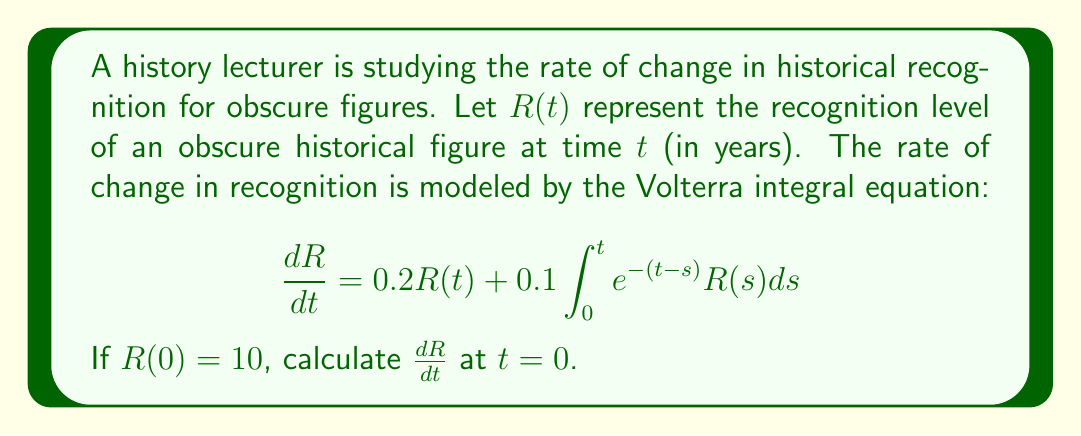What is the answer to this math problem? To solve this problem, we need to follow these steps:

1) The Volterra integral equation given is:
   $$\frac{dR}{dt} = 0.2R(t) + 0.1\int_0^t e^{-(t-s)}R(s)ds$$

2) We're asked to find $\frac{dR}{dt}$ at $t = 0$. At this point, the integral term becomes zero because the upper and lower limits of integration are the same:
   $$\int_0^0 e^{-(0-s)}R(s)ds = 0$$

3) Therefore, at $t = 0$, the equation simplifies to:
   $$\frac{dR}{dt} = 0.2R(0)$$

4) We're given that $R(0) = 10$, so we can substitute this:
   $$\frac{dR}{dt} = 0.2 \cdot 10$$

5) Calculating this:
   $$\frac{dR}{dt} = 2$$

Thus, at $t = 0$, the rate of change in historical recognition is 2 units per year.
Answer: $\frac{dR}{dt} = 2$ at $t = 0$ 